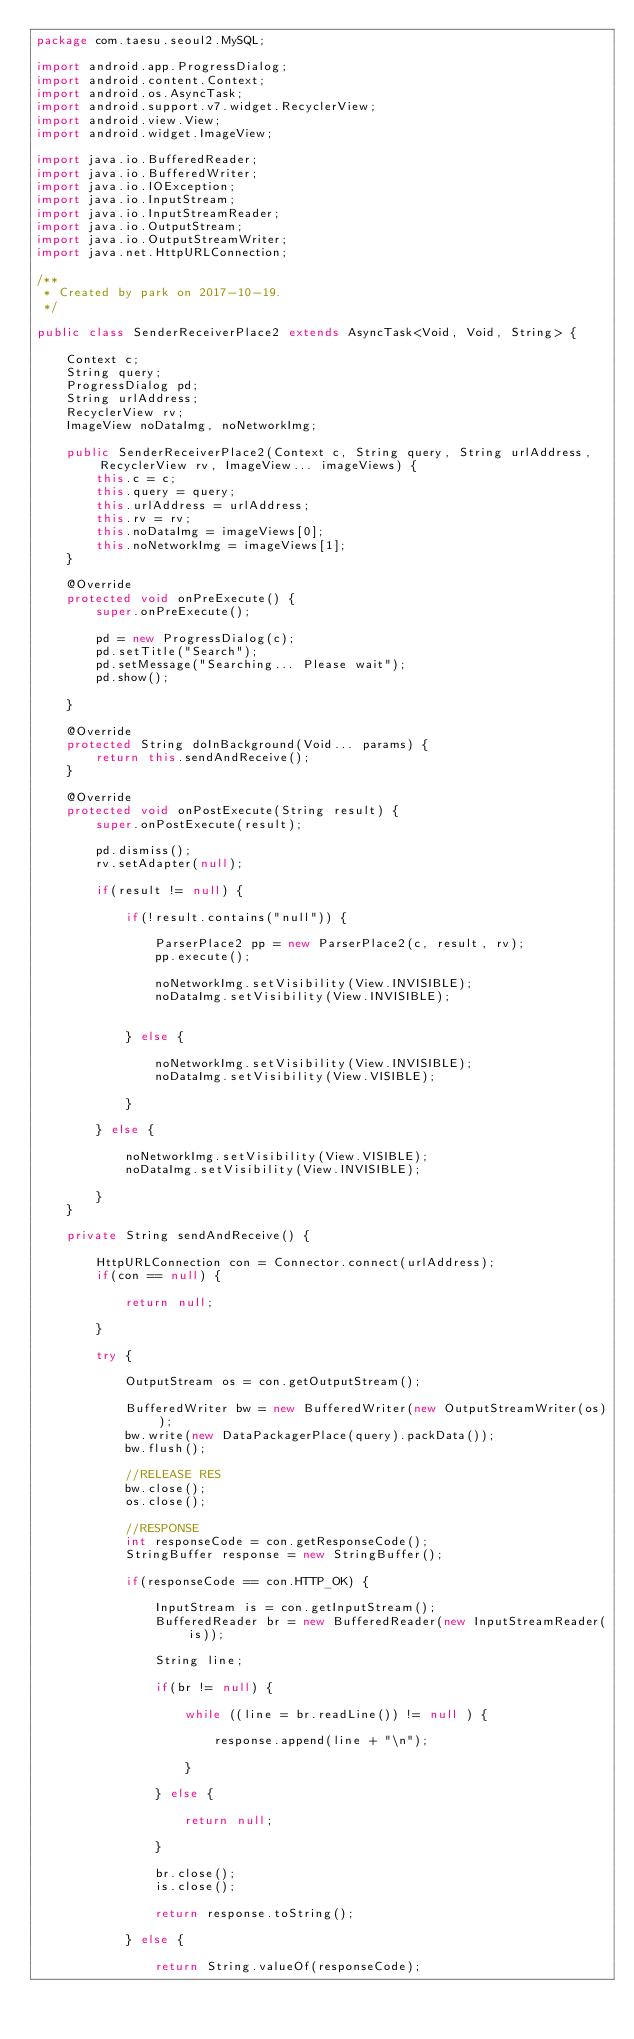<code> <loc_0><loc_0><loc_500><loc_500><_Java_>package com.taesu.seoul2.MySQL;

import android.app.ProgressDialog;
import android.content.Context;
import android.os.AsyncTask;
import android.support.v7.widget.RecyclerView;
import android.view.View;
import android.widget.ImageView;

import java.io.BufferedReader;
import java.io.BufferedWriter;
import java.io.IOException;
import java.io.InputStream;
import java.io.InputStreamReader;
import java.io.OutputStream;
import java.io.OutputStreamWriter;
import java.net.HttpURLConnection;

/**
 * Created by park on 2017-10-19.
 */

public class SenderReceiverPlace2 extends AsyncTask<Void, Void, String> {

    Context c;
    String query;
    ProgressDialog pd;
    String urlAddress;
    RecyclerView rv;
    ImageView noDataImg, noNetworkImg;

    public SenderReceiverPlace2(Context c, String query, String urlAddress, RecyclerView rv, ImageView... imageViews) {
        this.c = c;
        this.query = query;
        this.urlAddress = urlAddress;
        this.rv = rv;
        this.noDataImg = imageViews[0];
        this.noNetworkImg = imageViews[1];
    }

    @Override
    protected void onPreExecute() {
        super.onPreExecute();

        pd = new ProgressDialog(c);
        pd.setTitle("Search");
        pd.setMessage("Searching... Please wait");
        pd.show();

    }

    @Override
    protected String doInBackground(Void... params) {
        return this.sendAndReceive();
    }

    @Override
    protected void onPostExecute(String result) {
        super.onPostExecute(result);

        pd.dismiss();
        rv.setAdapter(null);

        if(result != null) {

            if(!result.contains("null")) {

                ParserPlace2 pp = new ParserPlace2(c, result, rv);
                pp.execute();

                noNetworkImg.setVisibility(View.INVISIBLE);
                noDataImg.setVisibility(View.INVISIBLE);


            } else {

                noNetworkImg.setVisibility(View.INVISIBLE);
                noDataImg.setVisibility(View.VISIBLE);

            }

        } else {

            noNetworkImg.setVisibility(View.VISIBLE);
            noDataImg.setVisibility(View.INVISIBLE);

        }
    }

    private String sendAndReceive() {

        HttpURLConnection con = Connector.connect(urlAddress);
        if(con == null) {

            return null;

        }

        try {

            OutputStream os = con.getOutputStream();

            BufferedWriter bw = new BufferedWriter(new OutputStreamWriter(os));
            bw.write(new DataPackagerPlace(query).packData());
            bw.flush();

            //RELEASE RES
            bw.close();
            os.close();

            //RESPONSE
            int responseCode = con.getResponseCode();
            StringBuffer response = new StringBuffer();

            if(responseCode == con.HTTP_OK) {

                InputStream is = con.getInputStream();
                BufferedReader br = new BufferedReader(new InputStreamReader(is));

                String line;

                if(br != null) {

                    while ((line = br.readLine()) != null ) {

                        response.append(line + "\n");

                    }

                } else {

                    return null;

                }

                br.close();
                is.close();

                return response.toString();

            } else {

                return String.valueOf(responseCode);
</code> 